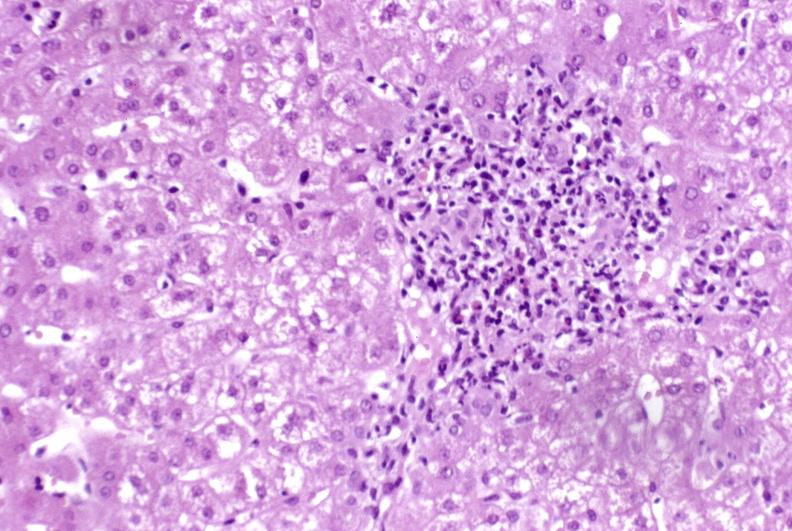what does this image show?
Answer the question using a single word or phrase. Moderate acute rejection 